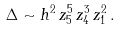<formula> <loc_0><loc_0><loc_500><loc_500>\Delta \sim h ^ { 2 } \, z _ { 5 } ^ { 5 } \, z _ { 4 } ^ { 3 } \, z _ { 1 } ^ { 2 } \, .</formula> 